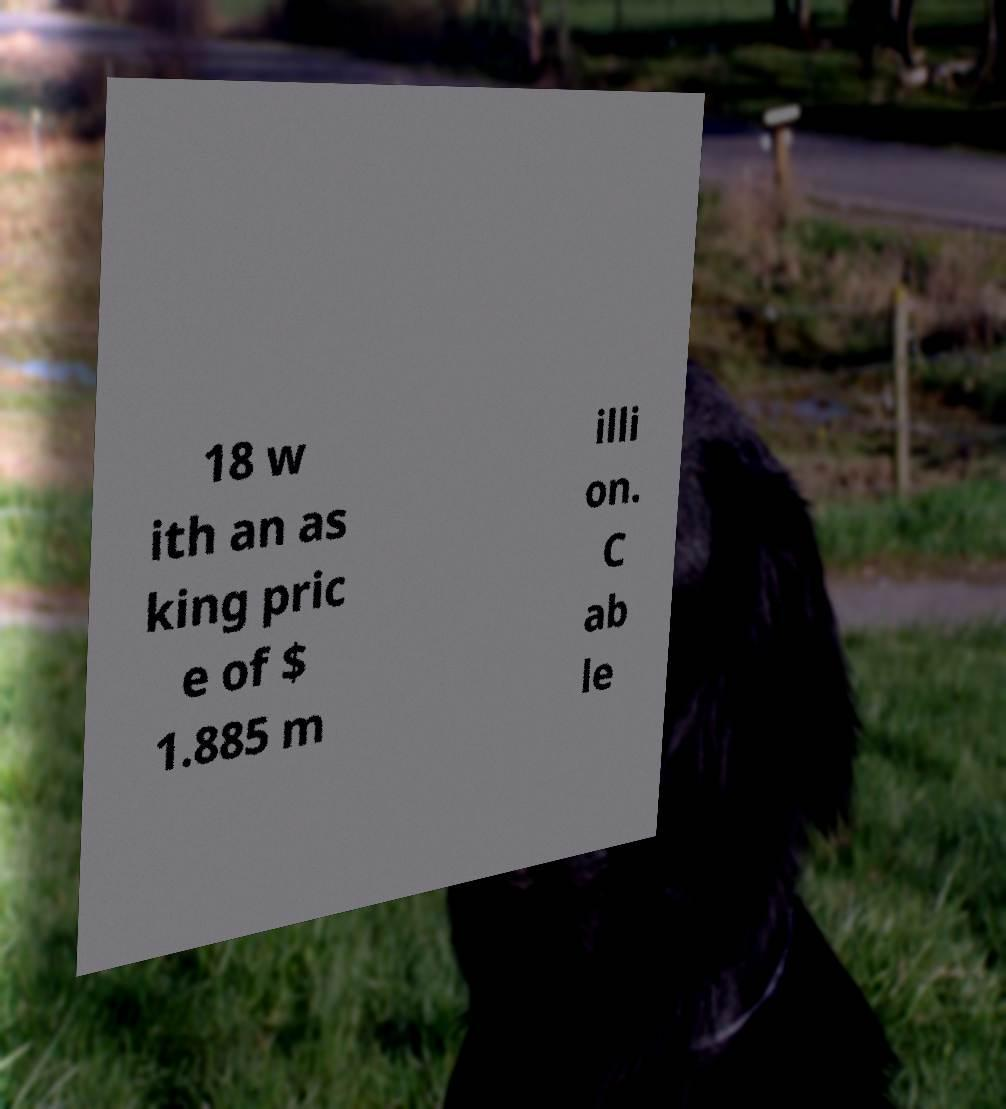What messages or text are displayed in this image? I need them in a readable, typed format. 18 w ith an as king pric e of $ 1.885 m illi on. C ab le 